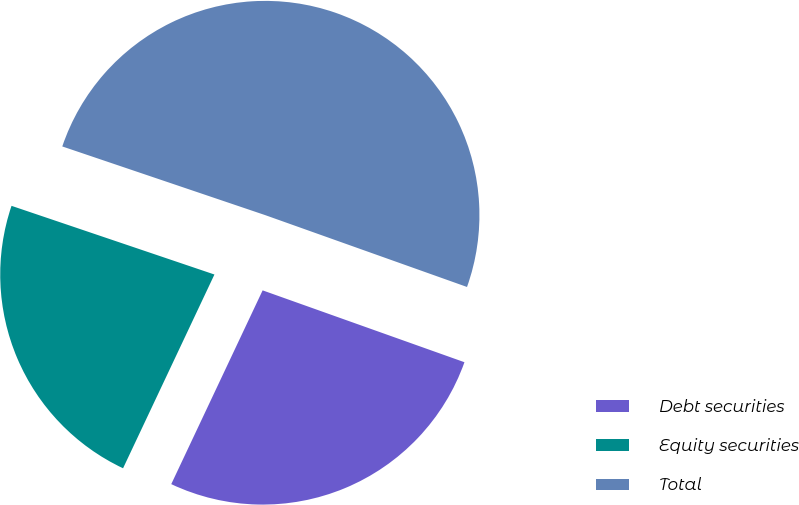Convert chart to OTSL. <chart><loc_0><loc_0><loc_500><loc_500><pie_chart><fcel>Debt securities<fcel>Equity securities<fcel>Total<nl><fcel>26.57%<fcel>23.18%<fcel>50.25%<nl></chart> 